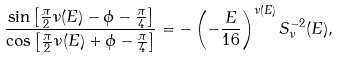Convert formula to latex. <formula><loc_0><loc_0><loc_500><loc_500>\frac { \sin \left [ \frac { \pi } { 2 } \nu ( E ) - \phi - \frac { \pi } { 4 } \right ] } { \cos \left [ \frac { \pi } { 2 } \nu ( E ) + \phi - \frac { \pi } { 4 } \right ] } = - \left ( - \frac { E } { 1 6 } \right ) ^ { \nu ( E ) } S _ { \nu } ^ { - 2 } ( E ) ,</formula> 